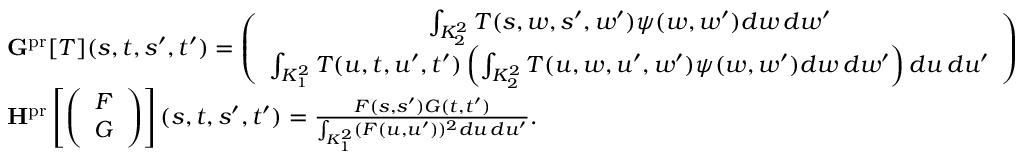<formula> <loc_0><loc_0><loc_500><loc_500>\begin{array} { r l } & { G ^ { p r } [ T ] ( s , t , s ^ { \prime } , t ^ { \prime } ) = \left ( \begin{array} { c } { \int _ { K _ { 2 } ^ { 2 } } T ( s , w , s ^ { \prime } , w ^ { \prime } ) \psi ( w , w ^ { \prime } ) d w \, d w ^ { \prime } } \\ { \int _ { K _ { 1 } ^ { 2 } } T ( u , t , u ^ { \prime } , t ^ { \prime } ) \left ( \int _ { K _ { 2 } ^ { 2 } } T ( u , w , u ^ { \prime } , w ^ { \prime } ) \psi ( w , w ^ { \prime } ) d w \, d w ^ { \prime } \right ) d u \, d u ^ { \prime } } \end{array} \right ) } \\ & { H ^ { p r } \left [ \left ( \begin{array} { c } { F } \\ { G } \end{array} \right ) \right ] ( s , t , s ^ { \prime } , t ^ { \prime } ) = \frac { F ( s , s ^ { \prime } ) G ( t , t ^ { \prime } ) } { \int _ { K _ { 1 } ^ { 2 } } ( F ( u , u ^ { \prime } ) ) ^ { 2 } d u \, d u ^ { \prime } } . } \end{array}</formula> 